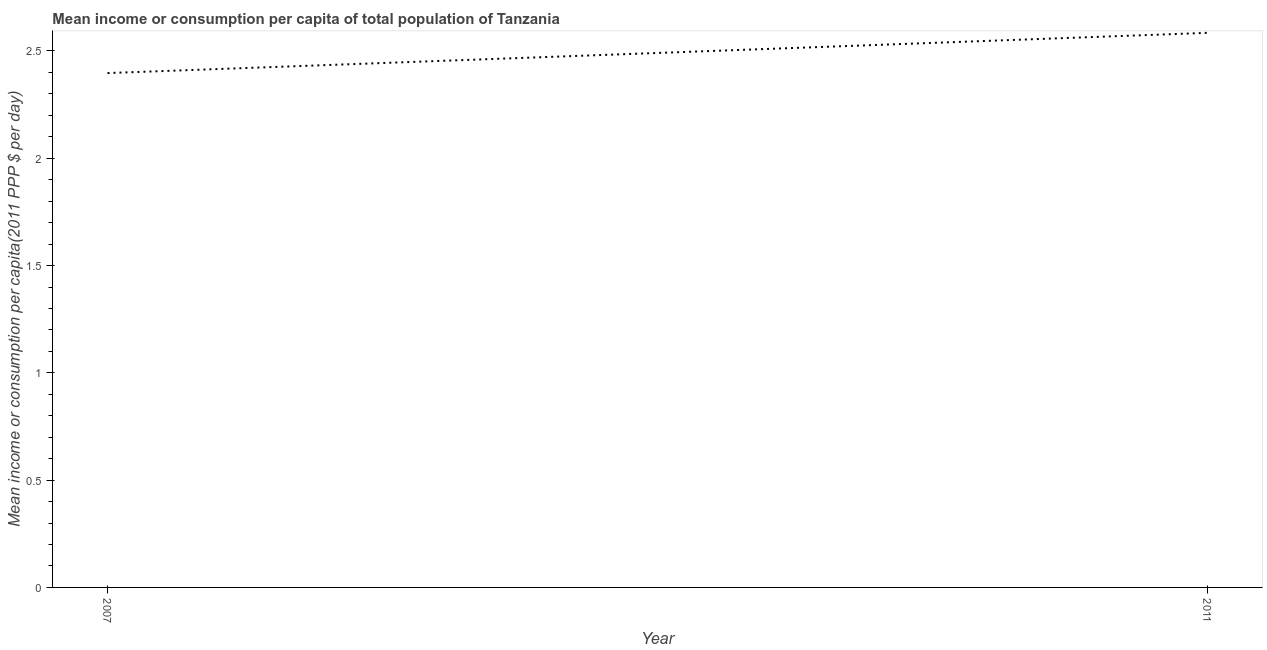What is the mean income or consumption in 2007?
Provide a short and direct response. 2.4. Across all years, what is the maximum mean income or consumption?
Provide a short and direct response. 2.58. Across all years, what is the minimum mean income or consumption?
Give a very brief answer. 2.4. In which year was the mean income or consumption maximum?
Your answer should be very brief. 2011. What is the sum of the mean income or consumption?
Give a very brief answer. 4.98. What is the difference between the mean income or consumption in 2007 and 2011?
Ensure brevity in your answer.  -0.19. What is the average mean income or consumption per year?
Give a very brief answer. 2.49. What is the median mean income or consumption?
Make the answer very short. 2.49. What is the ratio of the mean income or consumption in 2007 to that in 2011?
Offer a very short reply. 0.93. Does the graph contain any zero values?
Your answer should be compact. No. What is the title of the graph?
Keep it short and to the point. Mean income or consumption per capita of total population of Tanzania. What is the label or title of the Y-axis?
Your answer should be compact. Mean income or consumption per capita(2011 PPP $ per day). What is the Mean income or consumption per capita(2011 PPP $ per day) in 2007?
Offer a very short reply. 2.4. What is the Mean income or consumption per capita(2011 PPP $ per day) of 2011?
Offer a terse response. 2.58. What is the difference between the Mean income or consumption per capita(2011 PPP $ per day) in 2007 and 2011?
Provide a succinct answer. -0.19. What is the ratio of the Mean income or consumption per capita(2011 PPP $ per day) in 2007 to that in 2011?
Provide a succinct answer. 0.93. 